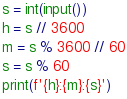Convert code to text. <code><loc_0><loc_0><loc_500><loc_500><_Python_>s = int(input())
h = s // 3600
m = s % 3600 // 60
s = s % 60
print(f'{h}:{m}:{s}')
</code> 